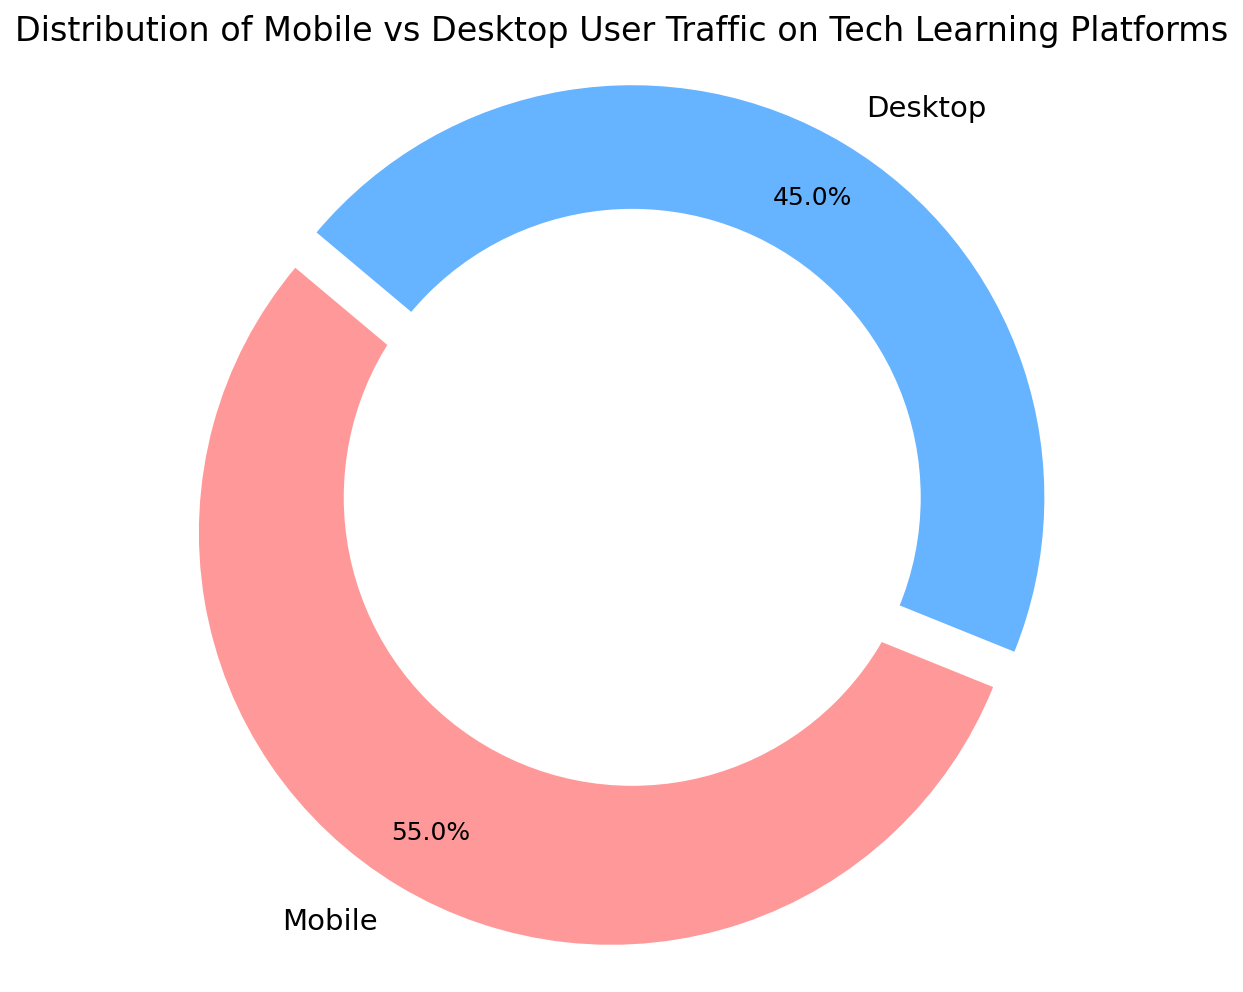What's the percentage of users using mobile devices? The pie chart shows the distribution of mobile vs desktop user traffic, where mobile usage is represented by one portion of the ring. The label "Mobile" shows 55%.
Answer: 55% What percentage of users access the tech learning platforms via desktop? The chart indicates the desktop usage as another segment of the ring with the label "Desktop", which shows 45%.
Answer: 45% Which device has a higher user percentage? By visually comparing the sizes of the segments, we notice that the "Mobile" segment is larger and is labeled with 55%, higher than the "Desktop" segment with 45%.
Answer: Mobile What's the sum of the percentages for both devices? Adding the percentages from both segments, Mobile (55%) and Desktop (45%), we get 55 + 45 = 100%.
Answer: 100% Is the mobile user percentage more than half of the total users? The percentage for mobile users is labelled as 55%, which is more than half of the total users (50%).
Answer: Yes By how much does mobile user percentage exceed desktop user percentage? The difference between the mobile and desktop percentages is calculated as 55% - 45% = 10%.
Answer: 10% What visual cue indicates that the mobile device segment is more significant than the desktop segment? The mobile segment is slightly separated (exploded) from the rest of the ring, which visually emphasizes its higher percentage.
Answer: Exploded segment What is the approximate difference in user percentage between the two devices? Subtracting the desktop percentage from the mobile percentage gives 55% - 45% = 10%.
Answer: 10% Which segment of the ring chart has been exploded? The segment representing mobile users is visually separated (exploded) from the chart.
Answer: Mobile What color represents the desktop user traffic in the ring chart? The desktop user traffic segment is shown in a blue shade in the ring chart.
Answer: Blue 